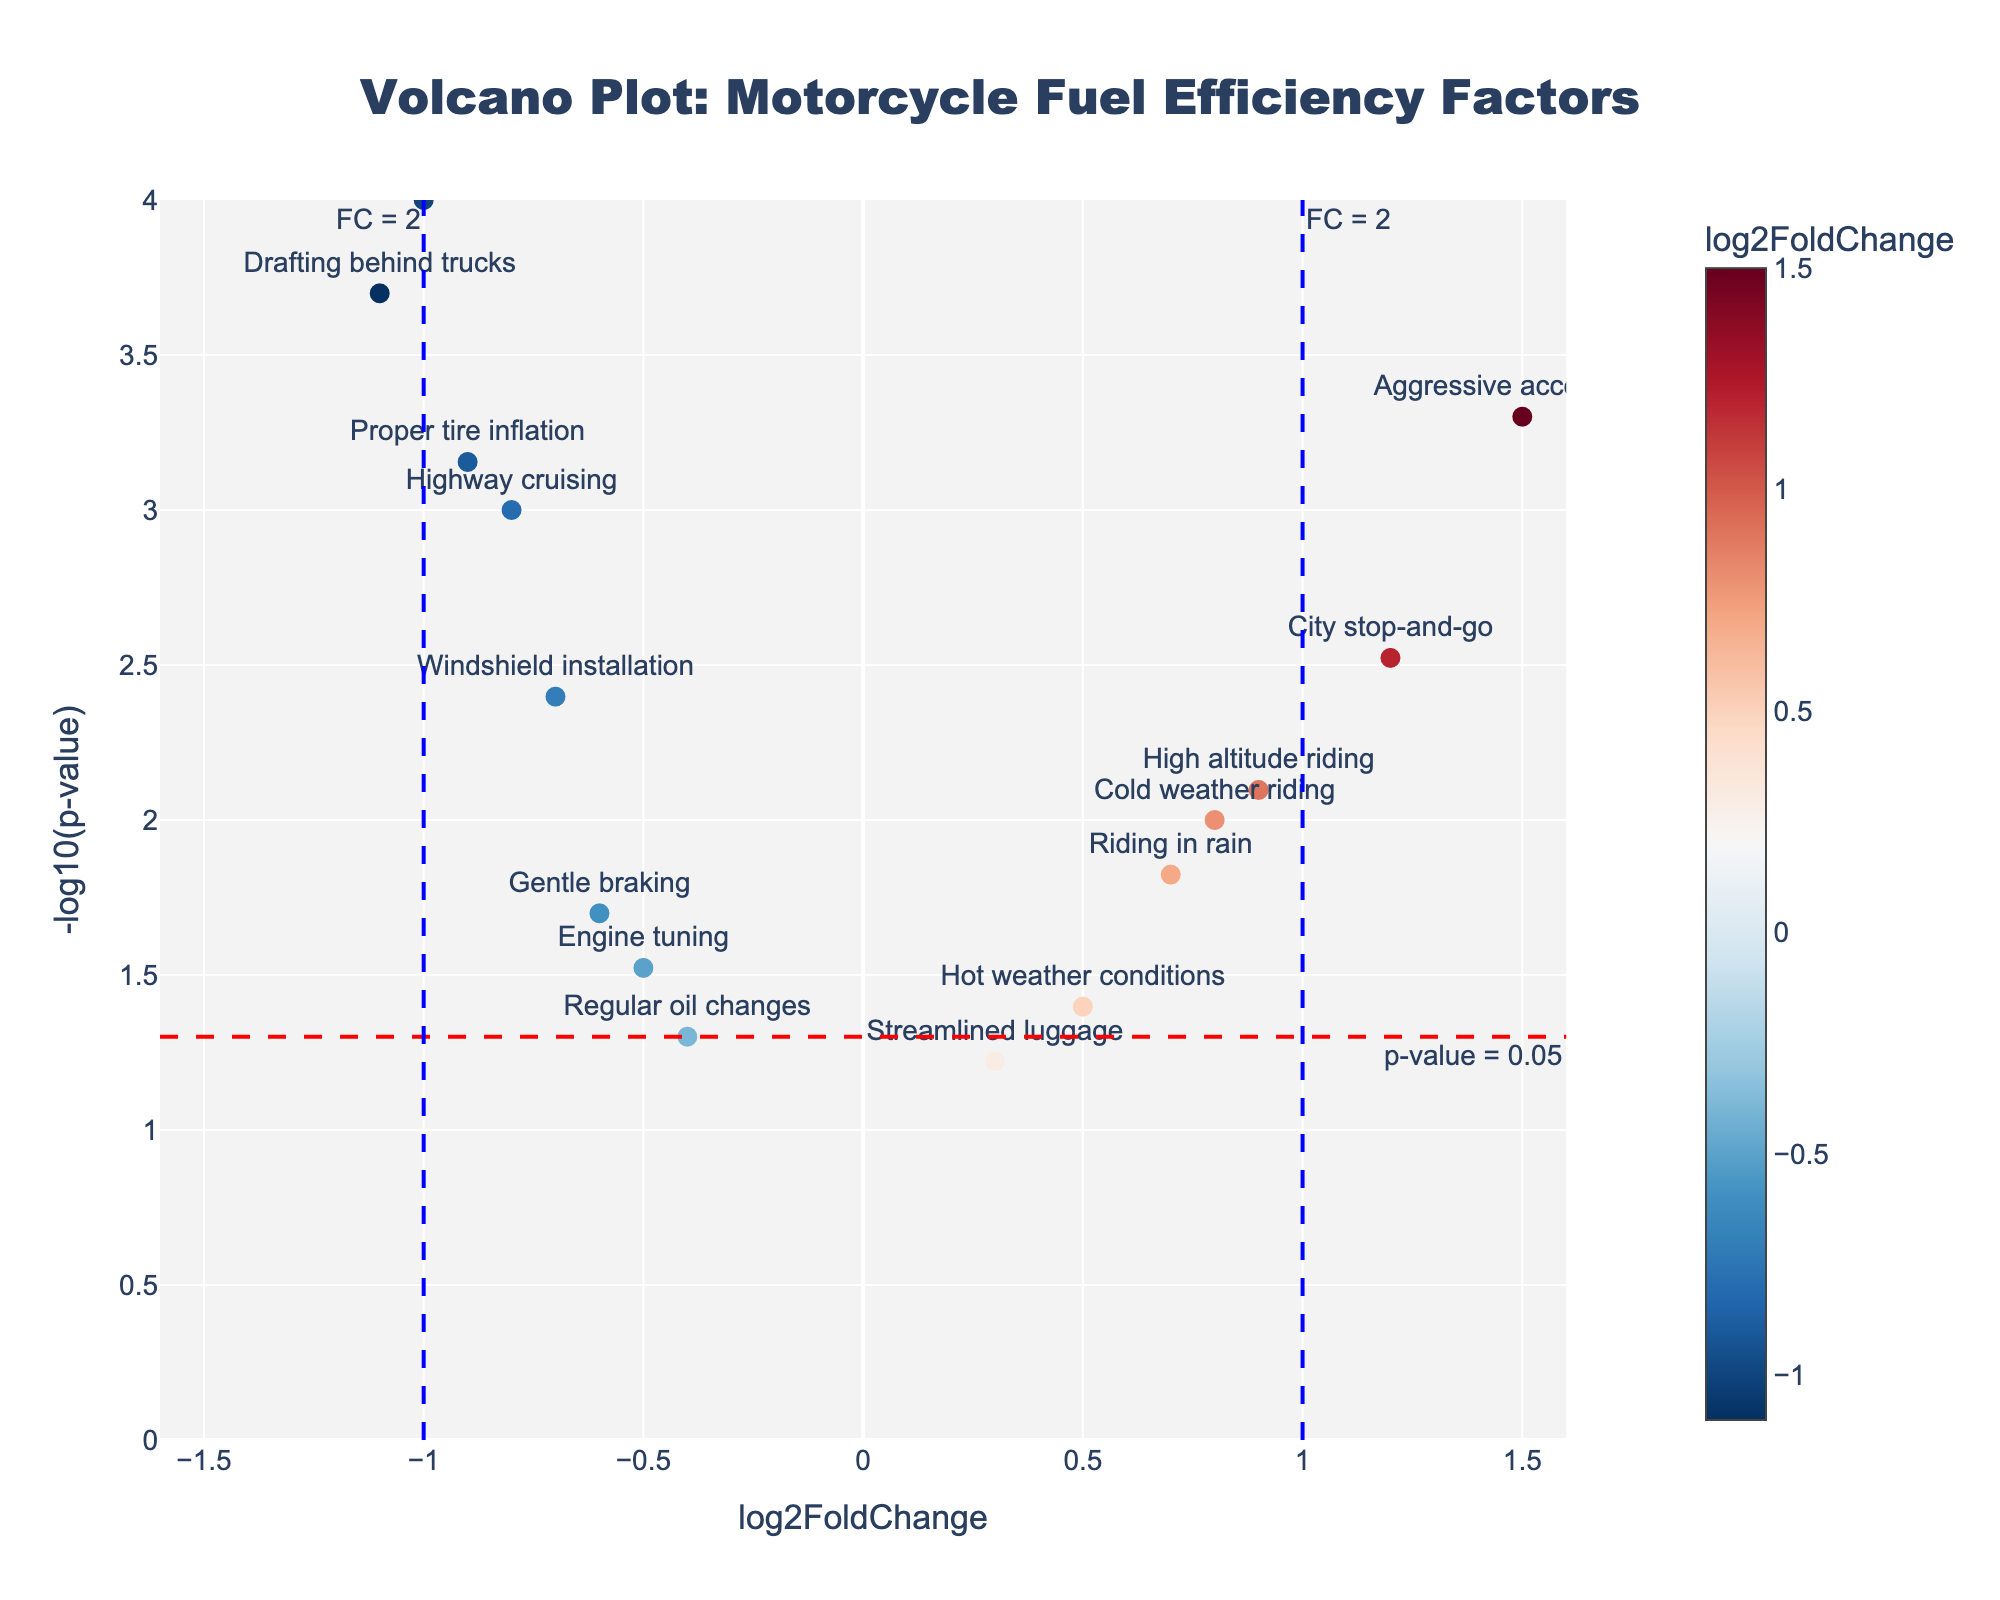What is the title of the volcano plot? The title is prominently displayed at the top of the figure. It is centered and has a larger font size compared to other text elements.
Answer: Volcano Plot: Motorcycle Fuel Efficiency Factors What does the red dashed horizontal line represent? The red dashed horizontal line represents the p-value threshold of 0.05. This line helps identify points that are statistically significant. It is annotated as "p-value = 0.05" and is positioned at -log10(0.05) on the y-axis.
Answer: p-value = 0.05 Which data point has the largest negative log2FoldChange? By looking at the x-axis values, we can see that "Weight reduction" has the farthest left log2FoldChange value at -1.0, indicating the largest negative change.
Answer: Weight reduction How many points are below the p-value threshold of 0.05? Points below the p-value threshold are above the red dashed line on the figure. By counting these points, we see "Highway cruising", "City stop-and-go", "Aggressive acceleration", "High altitude riding", "Drafting behind trucks", "Riding in rain", "Cold weather riding", "Proper tire inflation", "Windshield installation", and "Weight reduction" exceed this threshold.
Answer: 10 Which data point has the smallest p-value? The smallest p-value corresponds to the highest point on the y-axis. "Weight reduction" has the highest -log10(p-value) value, indicating the smallest p-value.
Answer: Weight reduction Which data points fall outside the fold change threshold lines (x=±1)? The vertical blue dashed lines indicate a fold change threshold of ±1 (FC = 2). Data points outside these lines are "Drafting behind trucks" and "Weight reduction" on the left, and "Aggressive acceleration" on the right.
Answer: Drafting behind trucks, Weight reduction, Aggressive acceleration What is the log2FoldChange and p-value of "City stop-and-go"? By hovering over the "City stop-and-go" point, we can see the hover text displays "City stop-and-go<br>log2FC: 1.20<br>p-value: 0.0030". This information indicates its log2FoldChange and p-value.
Answer: log2FoldChange: 1.20, p-value: 0.0030 Are there more techniques with a positive or negative log2FoldChange? Looking at the distribution along the x-axis, we count the techniques with positive log2FoldChange ("City stop-and-go", "Aggressive acceleration", "High altitude riding", "Riding in rain", "Hot weather conditions", "Cold weather riding", "Streamlined luggage") and negative log2FoldChange ("Highway cruising", "Gentle braking", "Drafting behind trucks", "Proper tire inflation", "Regular oil changes", "Windshield installation", "Weight reduction", "Engine tuning"). There are 7 positive and 8 negative.
Answer: Negative Which two techniques have almost the same log2FoldChange but different p-values? By examining the points with similar horizontal positions but different vertical positions, "High altitude riding" and "Cold weather riding" both have a similar log2FoldChange around 0.8-0.9 but different p-values as indicated by their different y-axis positions.
Answer: High altitude riding and Cold weather riding 